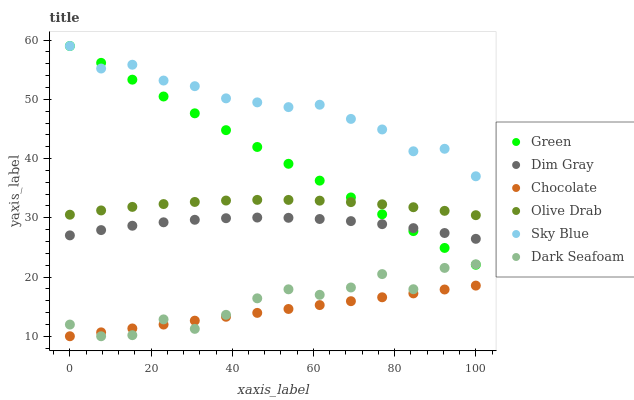Does Chocolate have the minimum area under the curve?
Answer yes or no. Yes. Does Sky Blue have the maximum area under the curve?
Answer yes or no. Yes. Does Dark Seafoam have the minimum area under the curve?
Answer yes or no. No. Does Dark Seafoam have the maximum area under the curve?
Answer yes or no. No. Is Chocolate the smoothest?
Answer yes or no. Yes. Is Dark Seafoam the roughest?
Answer yes or no. Yes. Is Dark Seafoam the smoothest?
Answer yes or no. No. Is Chocolate the roughest?
Answer yes or no. No. Does Chocolate have the lowest value?
Answer yes or no. Yes. Does Green have the lowest value?
Answer yes or no. No. Does Sky Blue have the highest value?
Answer yes or no. Yes. Does Dark Seafoam have the highest value?
Answer yes or no. No. Is Dim Gray less than Sky Blue?
Answer yes or no. Yes. Is Dim Gray greater than Chocolate?
Answer yes or no. Yes. Does Dim Gray intersect Green?
Answer yes or no. Yes. Is Dim Gray less than Green?
Answer yes or no. No. Is Dim Gray greater than Green?
Answer yes or no. No. Does Dim Gray intersect Sky Blue?
Answer yes or no. No. 